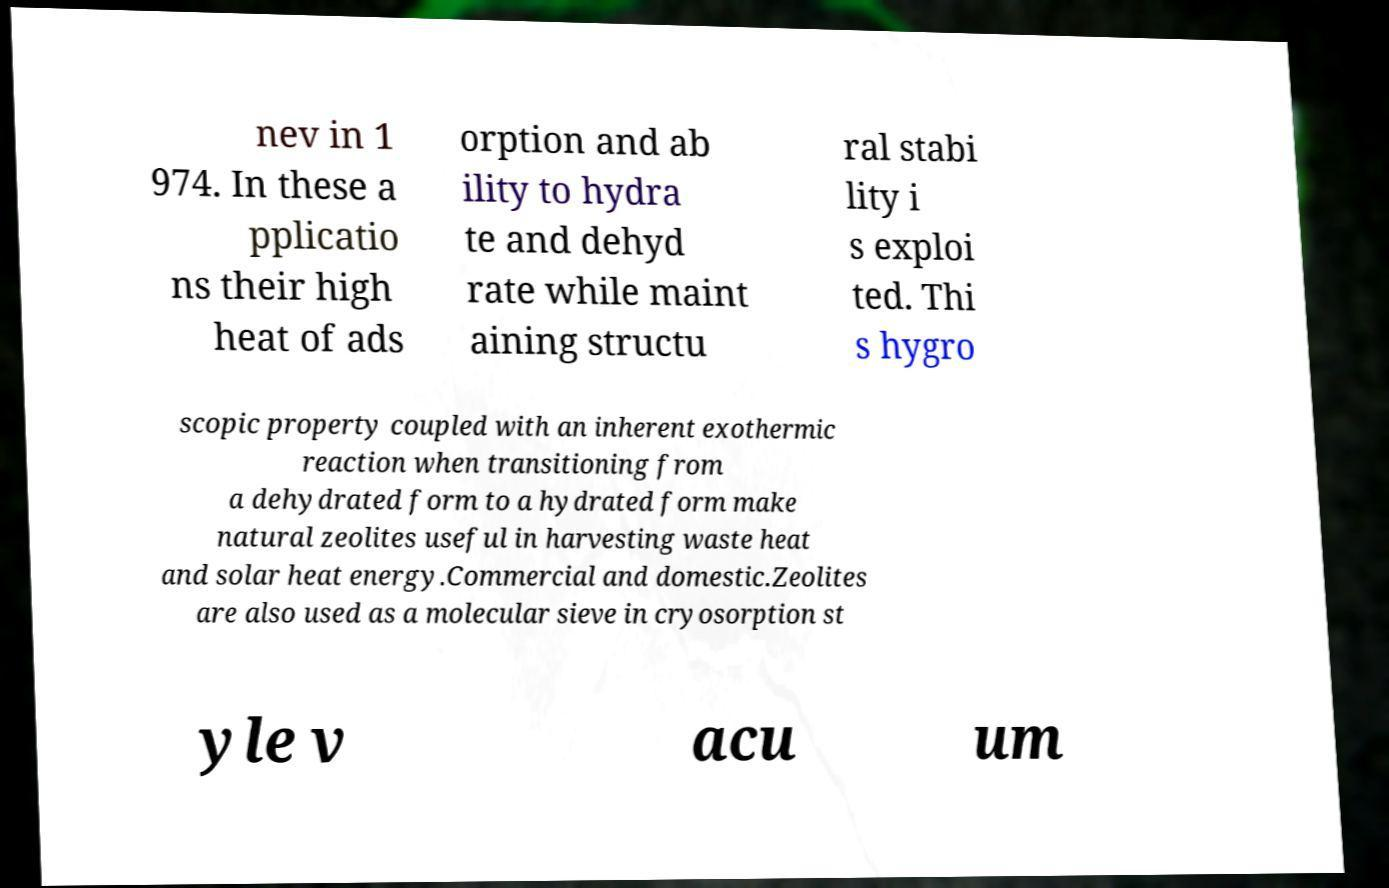There's text embedded in this image that I need extracted. Can you transcribe it verbatim? nev in 1 974. In these a pplicatio ns their high heat of ads orption and ab ility to hydra te and dehyd rate while maint aining structu ral stabi lity i s exploi ted. Thi s hygro scopic property coupled with an inherent exothermic reaction when transitioning from a dehydrated form to a hydrated form make natural zeolites useful in harvesting waste heat and solar heat energy.Commercial and domestic.Zeolites are also used as a molecular sieve in cryosorption st yle v acu um 